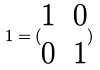<formula> <loc_0><loc_0><loc_500><loc_500>1 = ( \begin{matrix} 1 & 0 \\ 0 & 1 \end{matrix} )</formula> 